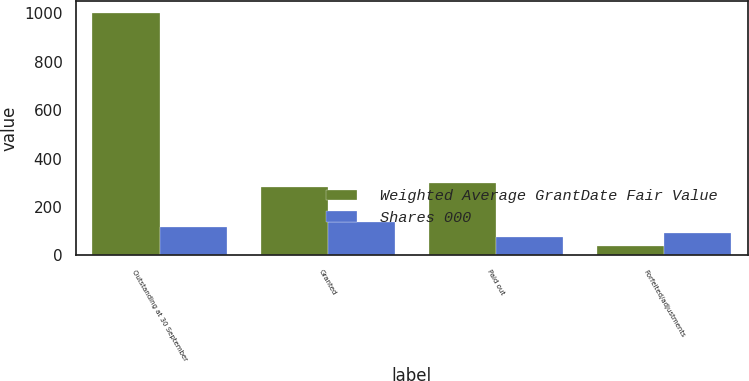Convert chart to OTSL. <chart><loc_0><loc_0><loc_500><loc_500><stacked_bar_chart><ecel><fcel>Outstanding at 30 September<fcel>Granted<fcel>Paid out<fcel>Forfeited/adjustments<nl><fcel>Weighted Average GrantDate Fair Value<fcel>1001<fcel>284<fcel>299<fcel>40<nl><fcel>Shares 000<fcel>119.44<fcel>136.37<fcel>77.81<fcel>90.83<nl></chart> 